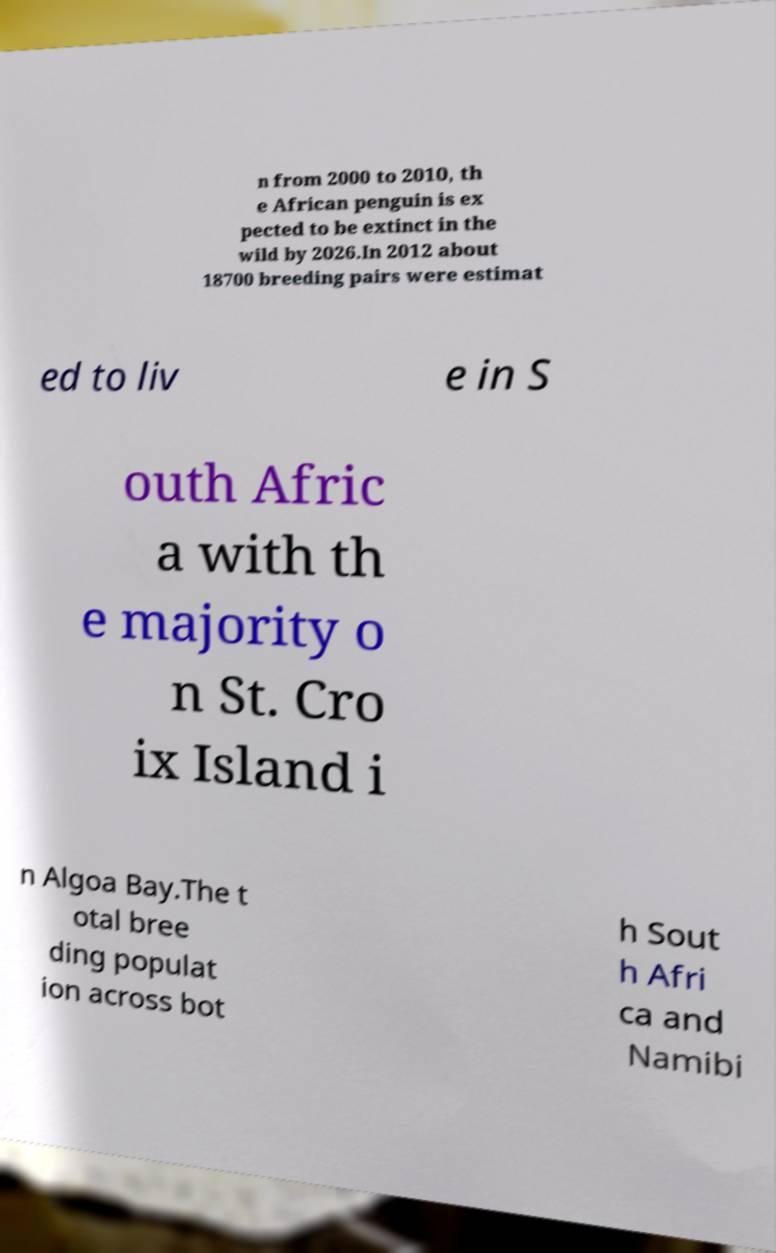Please read and relay the text visible in this image. What does it say? n from 2000 to 2010, th e African penguin is ex pected to be extinct in the wild by 2026.In 2012 about 18700 breeding pairs were estimat ed to liv e in S outh Afric a with th e majority o n St. Cro ix Island i n Algoa Bay.The t otal bree ding populat ion across bot h Sout h Afri ca and Namibi 